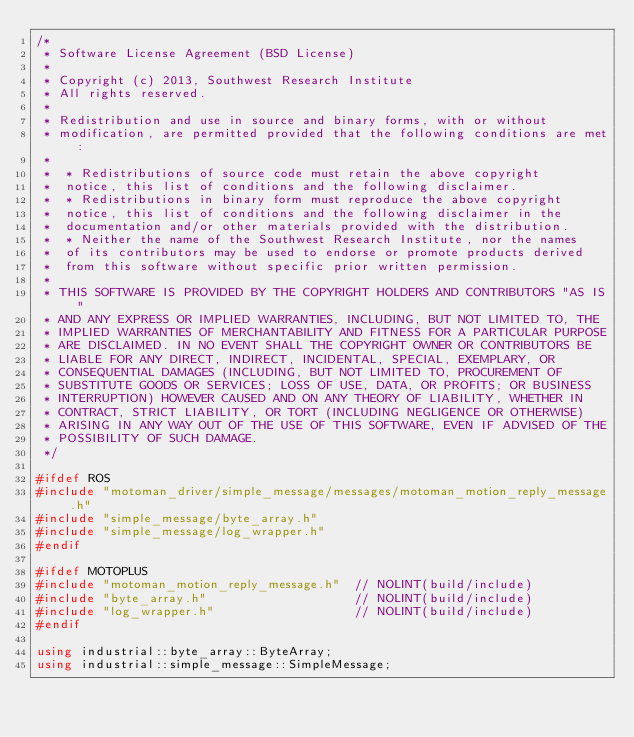Convert code to text. <code><loc_0><loc_0><loc_500><loc_500><_C++_>/*
 * Software License Agreement (BSD License)
 *
 * Copyright (c) 2013, Southwest Research Institute
 * All rights reserved.
 *
 * Redistribution and use in source and binary forms, with or without
 * modification, are permitted provided that the following conditions are met:
 *
 *  * Redistributions of source code must retain the above copyright
 *  notice, this list of conditions and the following disclaimer.
 *  * Redistributions in binary form must reproduce the above copyright
 *  notice, this list of conditions and the following disclaimer in the
 *  documentation and/or other materials provided with the distribution.
 *  * Neither the name of the Southwest Research Institute, nor the names
 *  of its contributors may be used to endorse or promote products derived
 *  from this software without specific prior written permission.
 *
 * THIS SOFTWARE IS PROVIDED BY THE COPYRIGHT HOLDERS AND CONTRIBUTORS "AS IS"
 * AND ANY EXPRESS OR IMPLIED WARRANTIES, INCLUDING, BUT NOT LIMITED TO, THE
 * IMPLIED WARRANTIES OF MERCHANTABILITY AND FITNESS FOR A PARTICULAR PURPOSE
 * ARE DISCLAIMED. IN NO EVENT SHALL THE COPYRIGHT OWNER OR CONTRIBUTORS BE
 * LIABLE FOR ANY DIRECT, INDIRECT, INCIDENTAL, SPECIAL, EXEMPLARY, OR
 * CONSEQUENTIAL DAMAGES (INCLUDING, BUT NOT LIMITED TO, PROCUREMENT OF
 * SUBSTITUTE GOODS OR SERVICES; LOSS OF USE, DATA, OR PROFITS; OR BUSINESS
 * INTERRUPTION) HOWEVER CAUSED AND ON ANY THEORY OF LIABILITY, WHETHER IN
 * CONTRACT, STRICT LIABILITY, OR TORT (INCLUDING NEGLIGENCE OR OTHERWISE)
 * ARISING IN ANY WAY OUT OF THE USE OF THIS SOFTWARE, EVEN IF ADVISED OF THE
 * POSSIBILITY OF SUCH DAMAGE.
 */

#ifdef ROS
#include "motoman_driver/simple_message/messages/motoman_motion_reply_message.h"
#include "simple_message/byte_array.h"
#include "simple_message/log_wrapper.h"
#endif

#ifdef MOTOPLUS
#include "motoman_motion_reply_message.h"  // NOLINT(build/include)
#include "byte_array.h"                    // NOLINT(build/include)
#include "log_wrapper.h"                   // NOLINT(build/include)
#endif

using industrial::byte_array::ByteArray;
using industrial::simple_message::SimpleMessage;</code> 